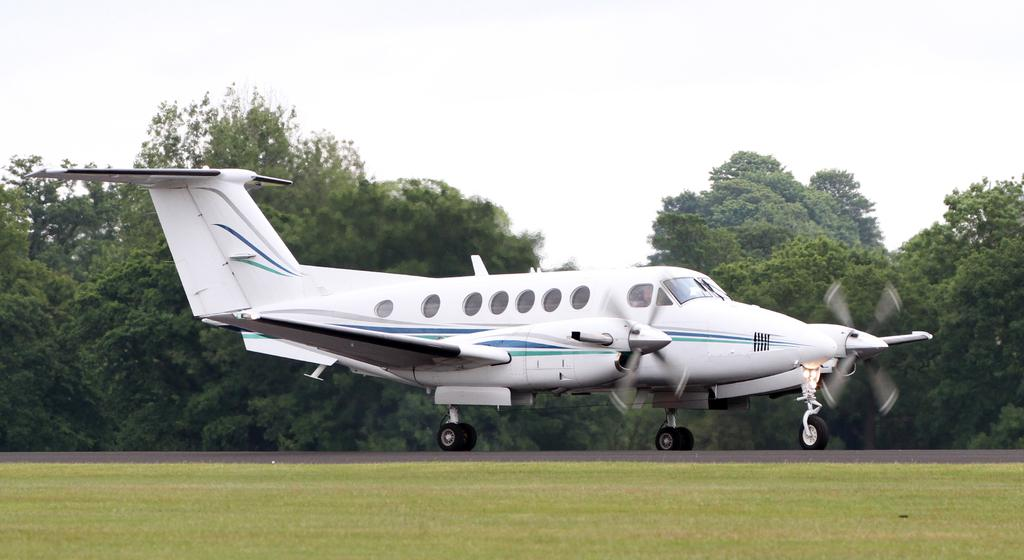What is the main subject of the image? The main subject of the image is a plane. Where is the plane located in the image? The plane is on the ground in the image. What type of vegetation is visible in the foreground of the image? There is grass in the foreground of the image. What can be seen in the background of the image? There are many trees in the background of the image. What type of haircut does the plane have in the image? The plane does not have a haircut, as it is an inanimate object and not a living being. 